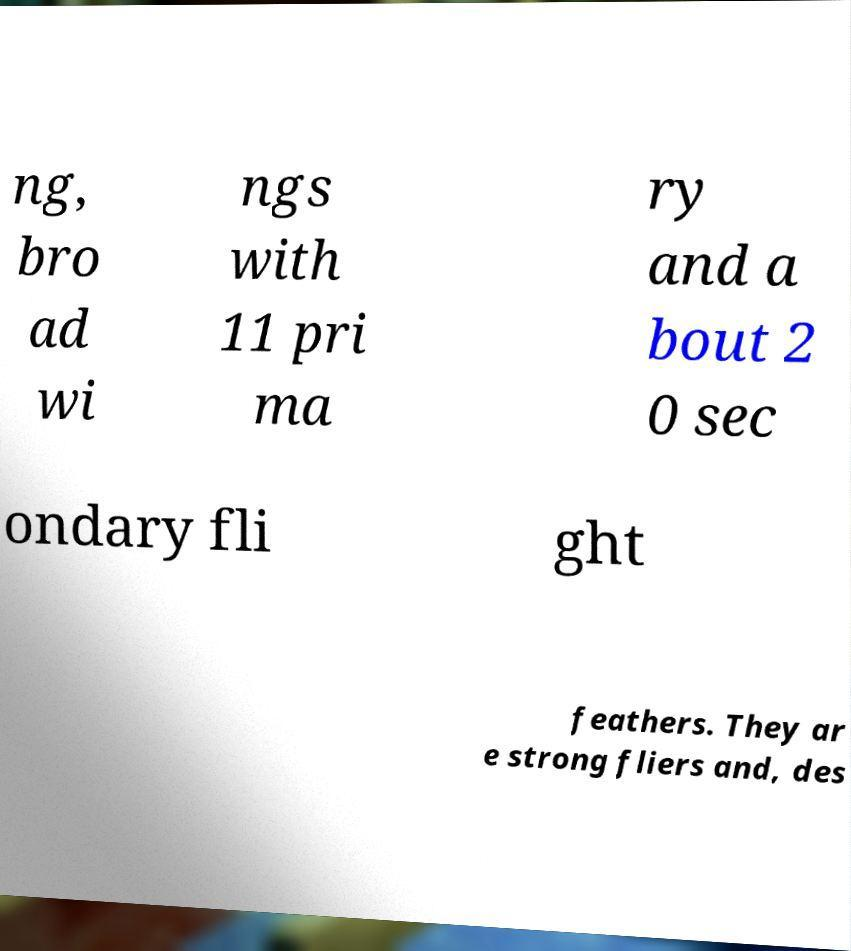Could you extract and type out the text from this image? ng, bro ad wi ngs with 11 pri ma ry and a bout 2 0 sec ondary fli ght feathers. They ar e strong fliers and, des 